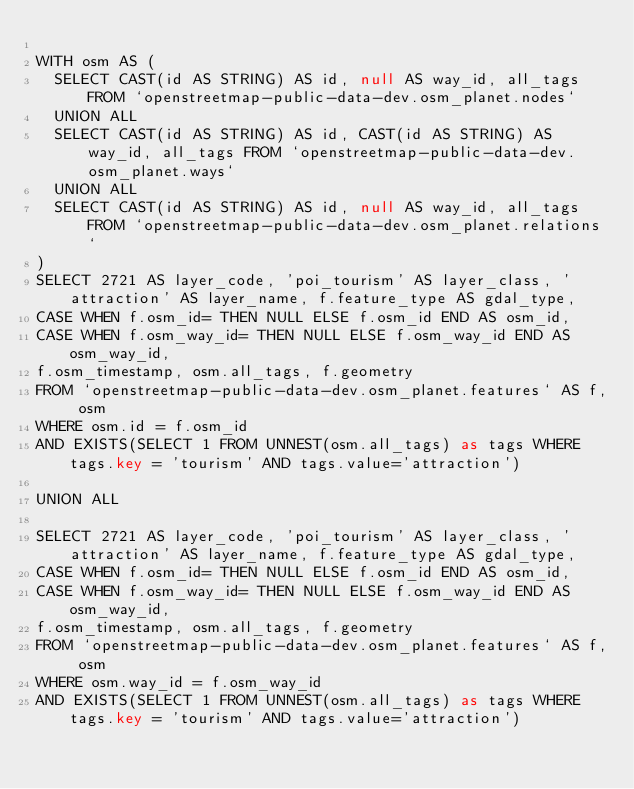Convert code to text. <code><loc_0><loc_0><loc_500><loc_500><_SQL_>
WITH osm AS (
  SELECT CAST(id AS STRING) AS id, null AS way_id, all_tags FROM `openstreetmap-public-data-dev.osm_planet.nodes`
  UNION ALL
  SELECT CAST(id AS STRING) AS id, CAST(id AS STRING) AS way_id, all_tags FROM `openstreetmap-public-data-dev.osm_planet.ways`
  UNION ALL
  SELECT CAST(id AS STRING) AS id, null AS way_id, all_tags FROM `openstreetmap-public-data-dev.osm_planet.relations`
)
SELECT 2721 AS layer_code, 'poi_tourism' AS layer_class, 'attraction' AS layer_name, f.feature_type AS gdal_type,
CASE WHEN f.osm_id= THEN NULL ELSE f.osm_id END AS osm_id,
CASE WHEN f.osm_way_id= THEN NULL ELSE f.osm_way_id END AS osm_way_id,
f.osm_timestamp, osm.all_tags, f.geometry
FROM `openstreetmap-public-data-dev.osm_planet.features` AS f, osm
WHERE osm.id = f.osm_id
AND EXISTS(SELECT 1 FROM UNNEST(osm.all_tags) as tags WHERE tags.key = 'tourism' AND tags.value='attraction')

UNION ALL

SELECT 2721 AS layer_code, 'poi_tourism' AS layer_class, 'attraction' AS layer_name, f.feature_type AS gdal_type,
CASE WHEN f.osm_id= THEN NULL ELSE f.osm_id END AS osm_id,
CASE WHEN f.osm_way_id= THEN NULL ELSE f.osm_way_id END AS osm_way_id,
f.osm_timestamp, osm.all_tags, f.geometry
FROM `openstreetmap-public-data-dev.osm_planet.features` AS f, osm
WHERE osm.way_id = f.osm_way_id
AND EXISTS(SELECT 1 FROM UNNEST(osm.all_tags) as tags WHERE tags.key = 'tourism' AND tags.value='attraction')

</code> 